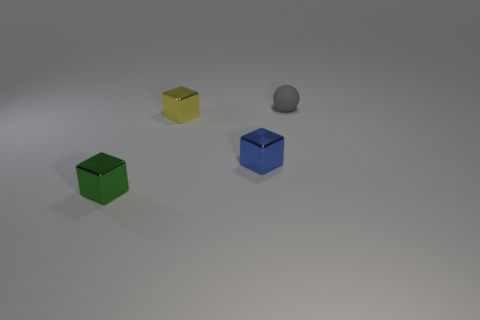Is the tiny object to the left of the yellow metal object made of the same material as the yellow object?
Your answer should be compact. Yes. What number of other things are made of the same material as the gray object?
Your response must be concise. 0. What is the blue thing made of?
Provide a succinct answer. Metal. How many tiny blue metallic blocks are behind the cube on the left side of the yellow shiny block?
Provide a short and direct response. 1. There is a blue metal thing that is to the right of the yellow block; is its shape the same as the object that is on the right side of the tiny blue cube?
Ensure brevity in your answer.  No. What number of things are in front of the small matte sphere and to the right of the green thing?
Keep it short and to the point. 2. Are there any tiny shiny blocks that have the same color as the matte object?
Give a very brief answer. No. What shape is the gray object that is the same size as the blue cube?
Offer a terse response. Sphere. Are there any tiny green metal blocks to the left of the small green metal block?
Keep it short and to the point. No. Are the thing that is on the right side of the small blue metallic thing and the small object that is in front of the blue object made of the same material?
Your response must be concise. No. 